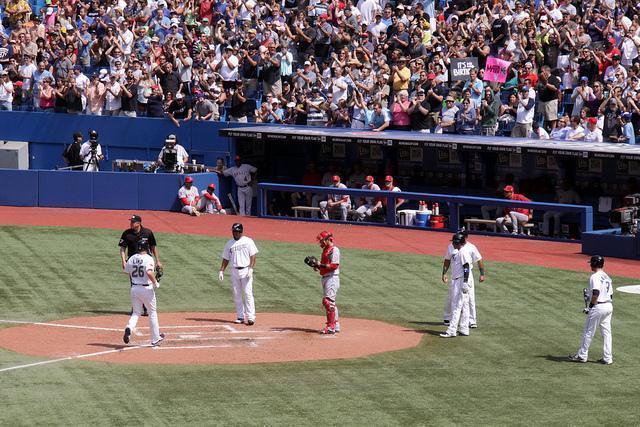How many people are there?
Give a very brief answer. 4. 